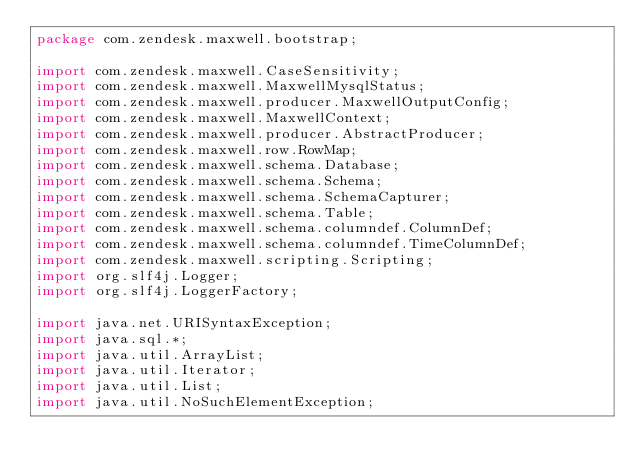<code> <loc_0><loc_0><loc_500><loc_500><_Java_>package com.zendesk.maxwell.bootstrap;

import com.zendesk.maxwell.CaseSensitivity;
import com.zendesk.maxwell.MaxwellMysqlStatus;
import com.zendesk.maxwell.producer.MaxwellOutputConfig;
import com.zendesk.maxwell.MaxwellContext;
import com.zendesk.maxwell.producer.AbstractProducer;
import com.zendesk.maxwell.row.RowMap;
import com.zendesk.maxwell.schema.Database;
import com.zendesk.maxwell.schema.Schema;
import com.zendesk.maxwell.schema.SchemaCapturer;
import com.zendesk.maxwell.schema.Table;
import com.zendesk.maxwell.schema.columndef.ColumnDef;
import com.zendesk.maxwell.schema.columndef.TimeColumnDef;
import com.zendesk.maxwell.scripting.Scripting;
import org.slf4j.Logger;
import org.slf4j.LoggerFactory;

import java.net.URISyntaxException;
import java.sql.*;
import java.util.ArrayList;
import java.util.Iterator;
import java.util.List;
import java.util.NoSuchElementException;
</code> 